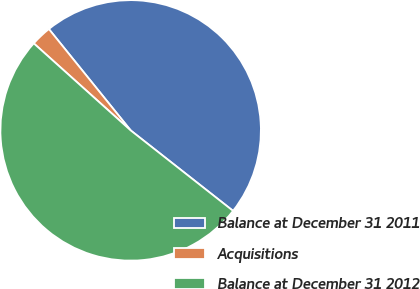Convert chart. <chart><loc_0><loc_0><loc_500><loc_500><pie_chart><fcel>Balance at December 31 2011<fcel>Acquisitions<fcel>Balance at December 31 2012<nl><fcel>46.41%<fcel>2.55%<fcel>51.05%<nl></chart> 